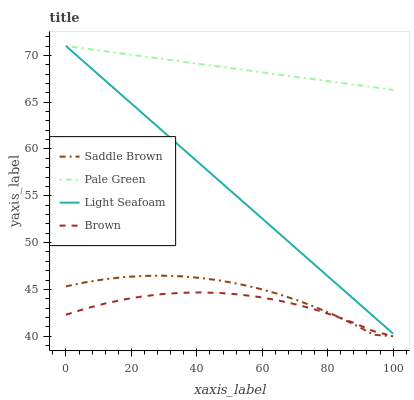Does Brown have the minimum area under the curve?
Answer yes or no. Yes. Does Pale Green have the maximum area under the curve?
Answer yes or no. Yes. Does Saddle Brown have the minimum area under the curve?
Answer yes or no. No. Does Saddle Brown have the maximum area under the curve?
Answer yes or no. No. Is Pale Green the smoothest?
Answer yes or no. Yes. Is Saddle Brown the roughest?
Answer yes or no. Yes. Is Saddle Brown the smoothest?
Answer yes or no. No. Is Pale Green the roughest?
Answer yes or no. No. Does Brown have the lowest value?
Answer yes or no. Yes. Does Pale Green have the lowest value?
Answer yes or no. No. Does Light Seafoam have the highest value?
Answer yes or no. Yes. Does Saddle Brown have the highest value?
Answer yes or no. No. Is Brown less than Light Seafoam?
Answer yes or no. Yes. Is Light Seafoam greater than Saddle Brown?
Answer yes or no. Yes. Does Saddle Brown intersect Brown?
Answer yes or no. Yes. Is Saddle Brown less than Brown?
Answer yes or no. No. Is Saddle Brown greater than Brown?
Answer yes or no. No. Does Brown intersect Light Seafoam?
Answer yes or no. No. 